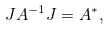<formula> <loc_0><loc_0><loc_500><loc_500>J A ^ { - 1 } J = A ^ { * } ,</formula> 